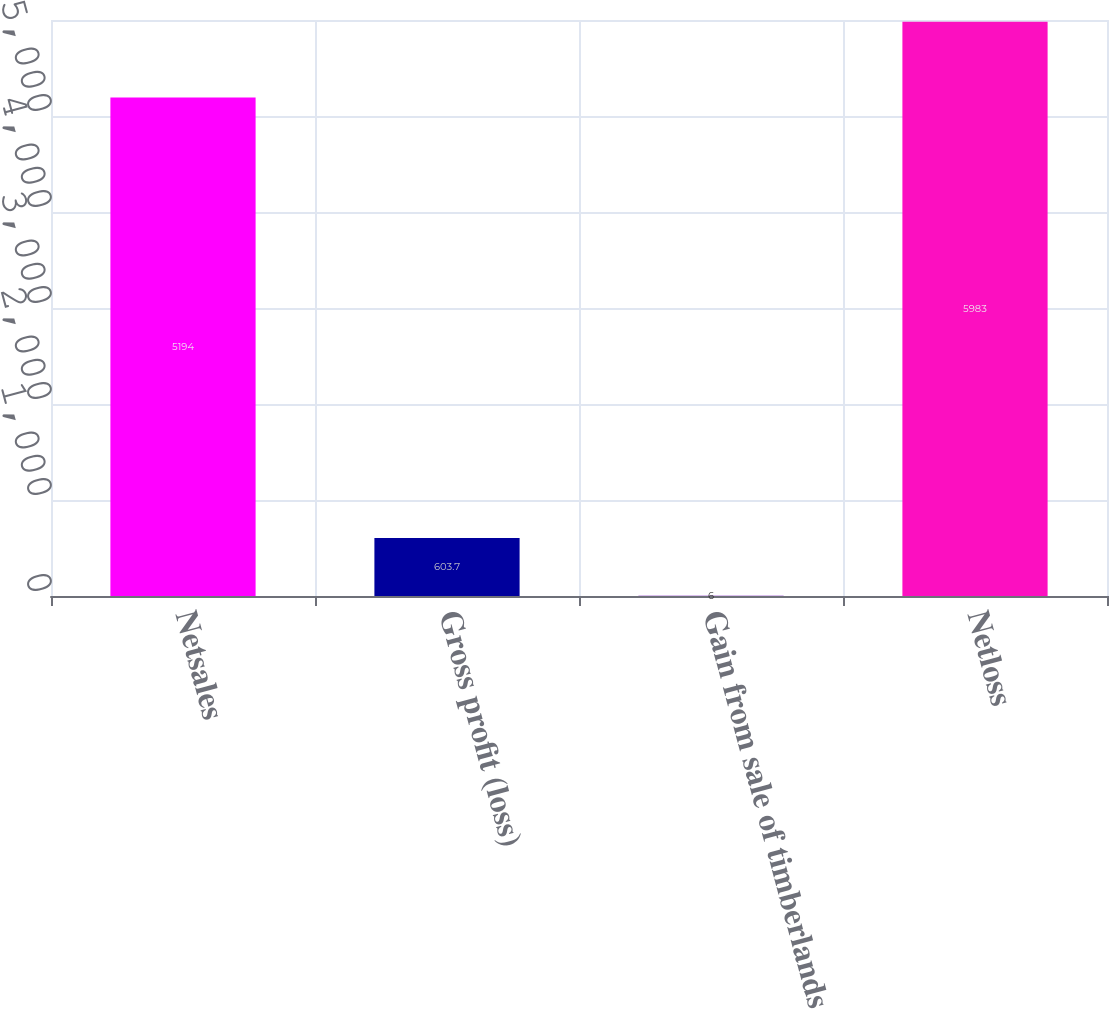Convert chart. <chart><loc_0><loc_0><loc_500><loc_500><bar_chart><fcel>Netsales<fcel>Gross profit (loss)<fcel>Gain from sale of timberlands<fcel>Netloss<nl><fcel>5194<fcel>603.7<fcel>6<fcel>5983<nl></chart> 